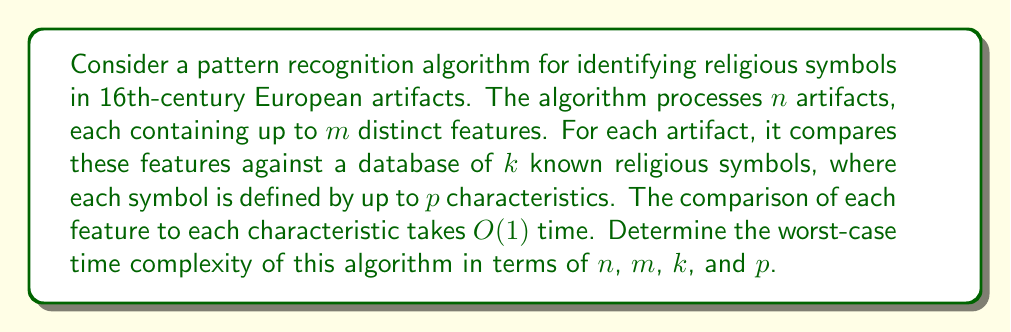Provide a solution to this math problem. To solve this problem, we need to analyze the algorithm's structure and determine its worst-case time complexity:

1. The algorithm processes $n$ artifacts.

2. For each artifact, it examines up to $m$ distinct features.

3. Each feature is compared against $k$ known religious symbols.

4. Each symbol is defined by up to $p$ characteristics.

5. The comparison of each feature to each characteristic takes $O(1)$ time.

Let's break down the nested operations:

- For each artifact (n iterations):
  - For each feature (m iterations):
    - For each known symbol (k iterations):
      - For each characteristic (p iterations):
        - Perform a constant-time comparison O(1)

This results in a nested loop structure with four levels.

The total number of constant-time operations in the worst case is:

$$n \times m \times k \times p \times O(1)$$

Since $O(1)$ is constant, we can simplify this to:

$$O(nmbp)$$

This represents the worst-case time complexity of the algorithm.

It's worth noting that this complexity assumes that all artifacts have the maximum number of features, all symbols have the maximum number of characteristics, and all comparisons need to be made. In practice, there might be optimizations that could improve the average-case performance, but the worst-case complexity remains $O(nmbp)$.
Answer: The worst-case time complexity of the algorithm is $O(nmbp)$. 